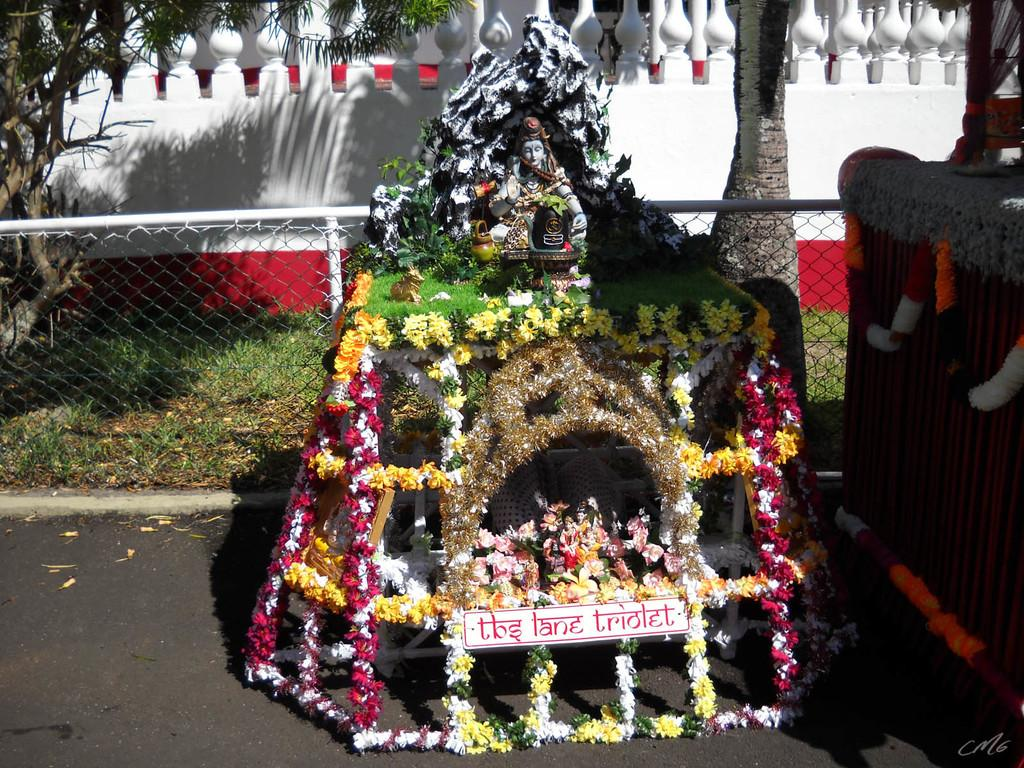What type of structure is present in the image? There is a small temple in the image. Where is the temple located? The temple is placed on the road. What can be seen in the background of the image? There is a fencing grill and a white color wall in the background of the image. What type of disgust can be seen in the image? There is no indication of disgust in the image; it features a small temple, a road, a fencing grill, and a white color wall in the background. 